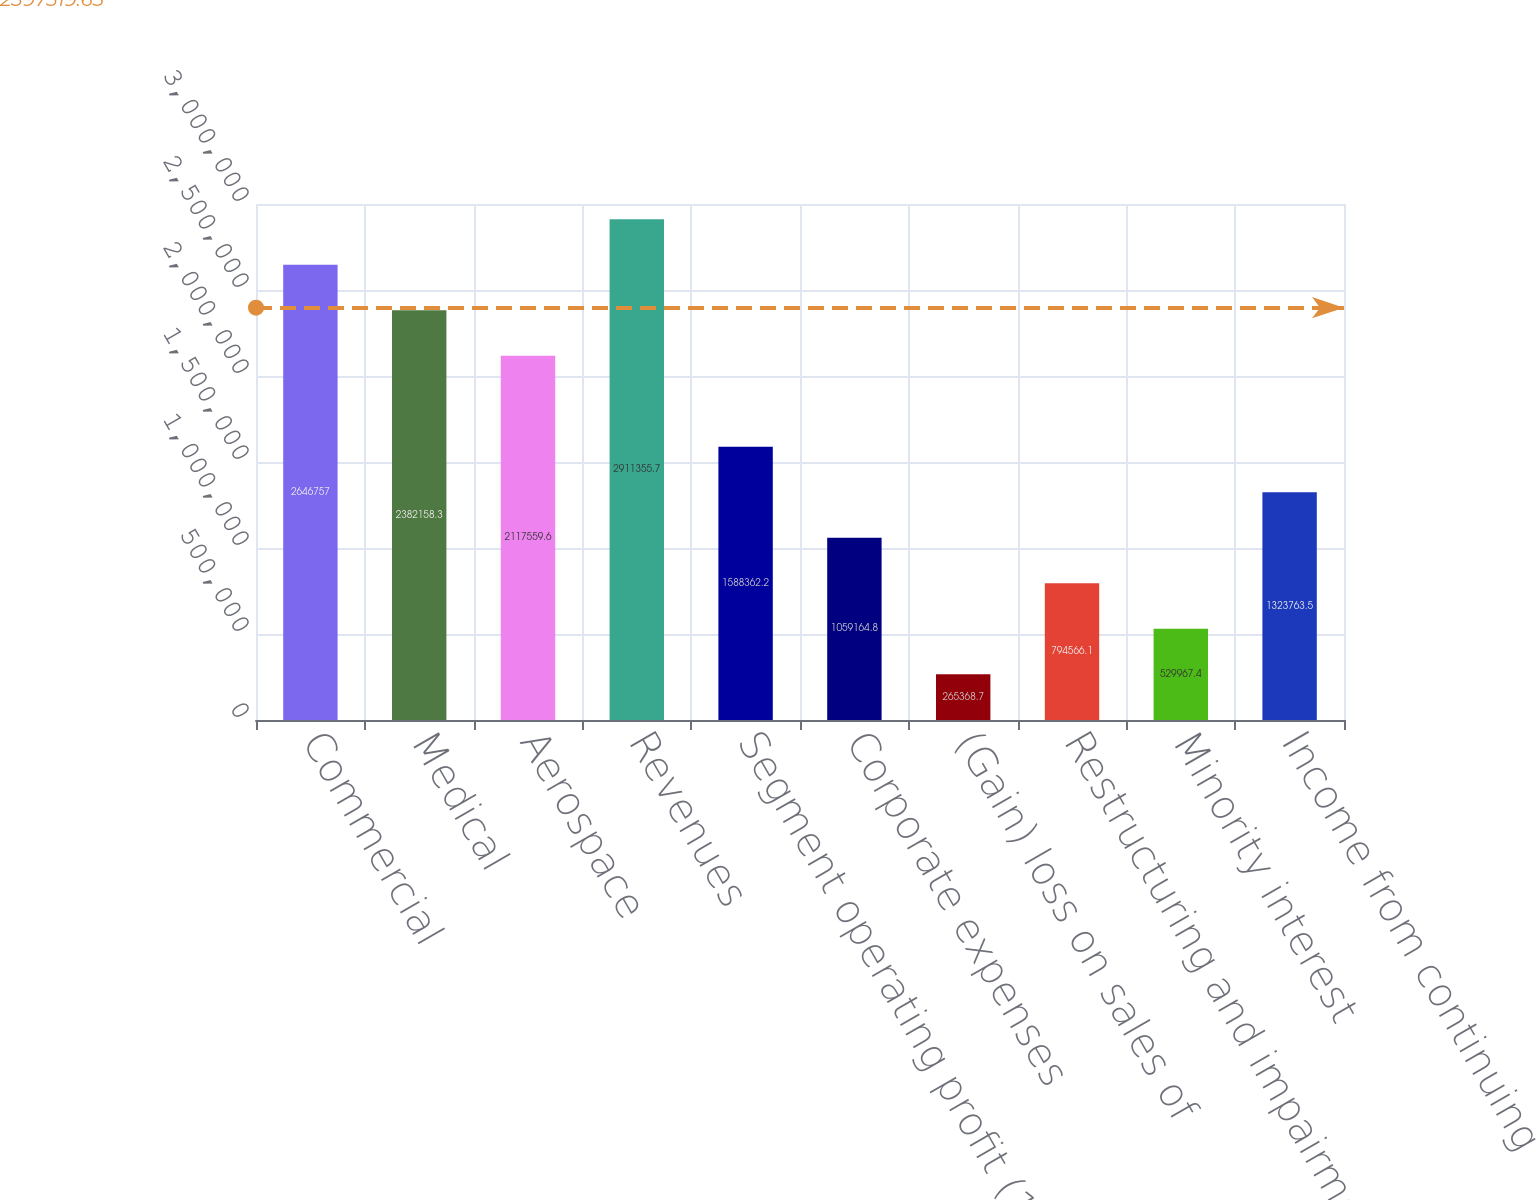Convert chart. <chart><loc_0><loc_0><loc_500><loc_500><bar_chart><fcel>Commercial<fcel>Medical<fcel>Aerospace<fcel>Revenues<fcel>Segment operating profit (1)<fcel>Corporate expenses<fcel>(Gain) loss on sales of<fcel>Restructuring and impairment<fcel>Minority interest<fcel>Income from continuing<nl><fcel>2.64676e+06<fcel>2.38216e+06<fcel>2.11756e+06<fcel>2.91136e+06<fcel>1.58836e+06<fcel>1.05916e+06<fcel>265369<fcel>794566<fcel>529967<fcel>1.32376e+06<nl></chart> 